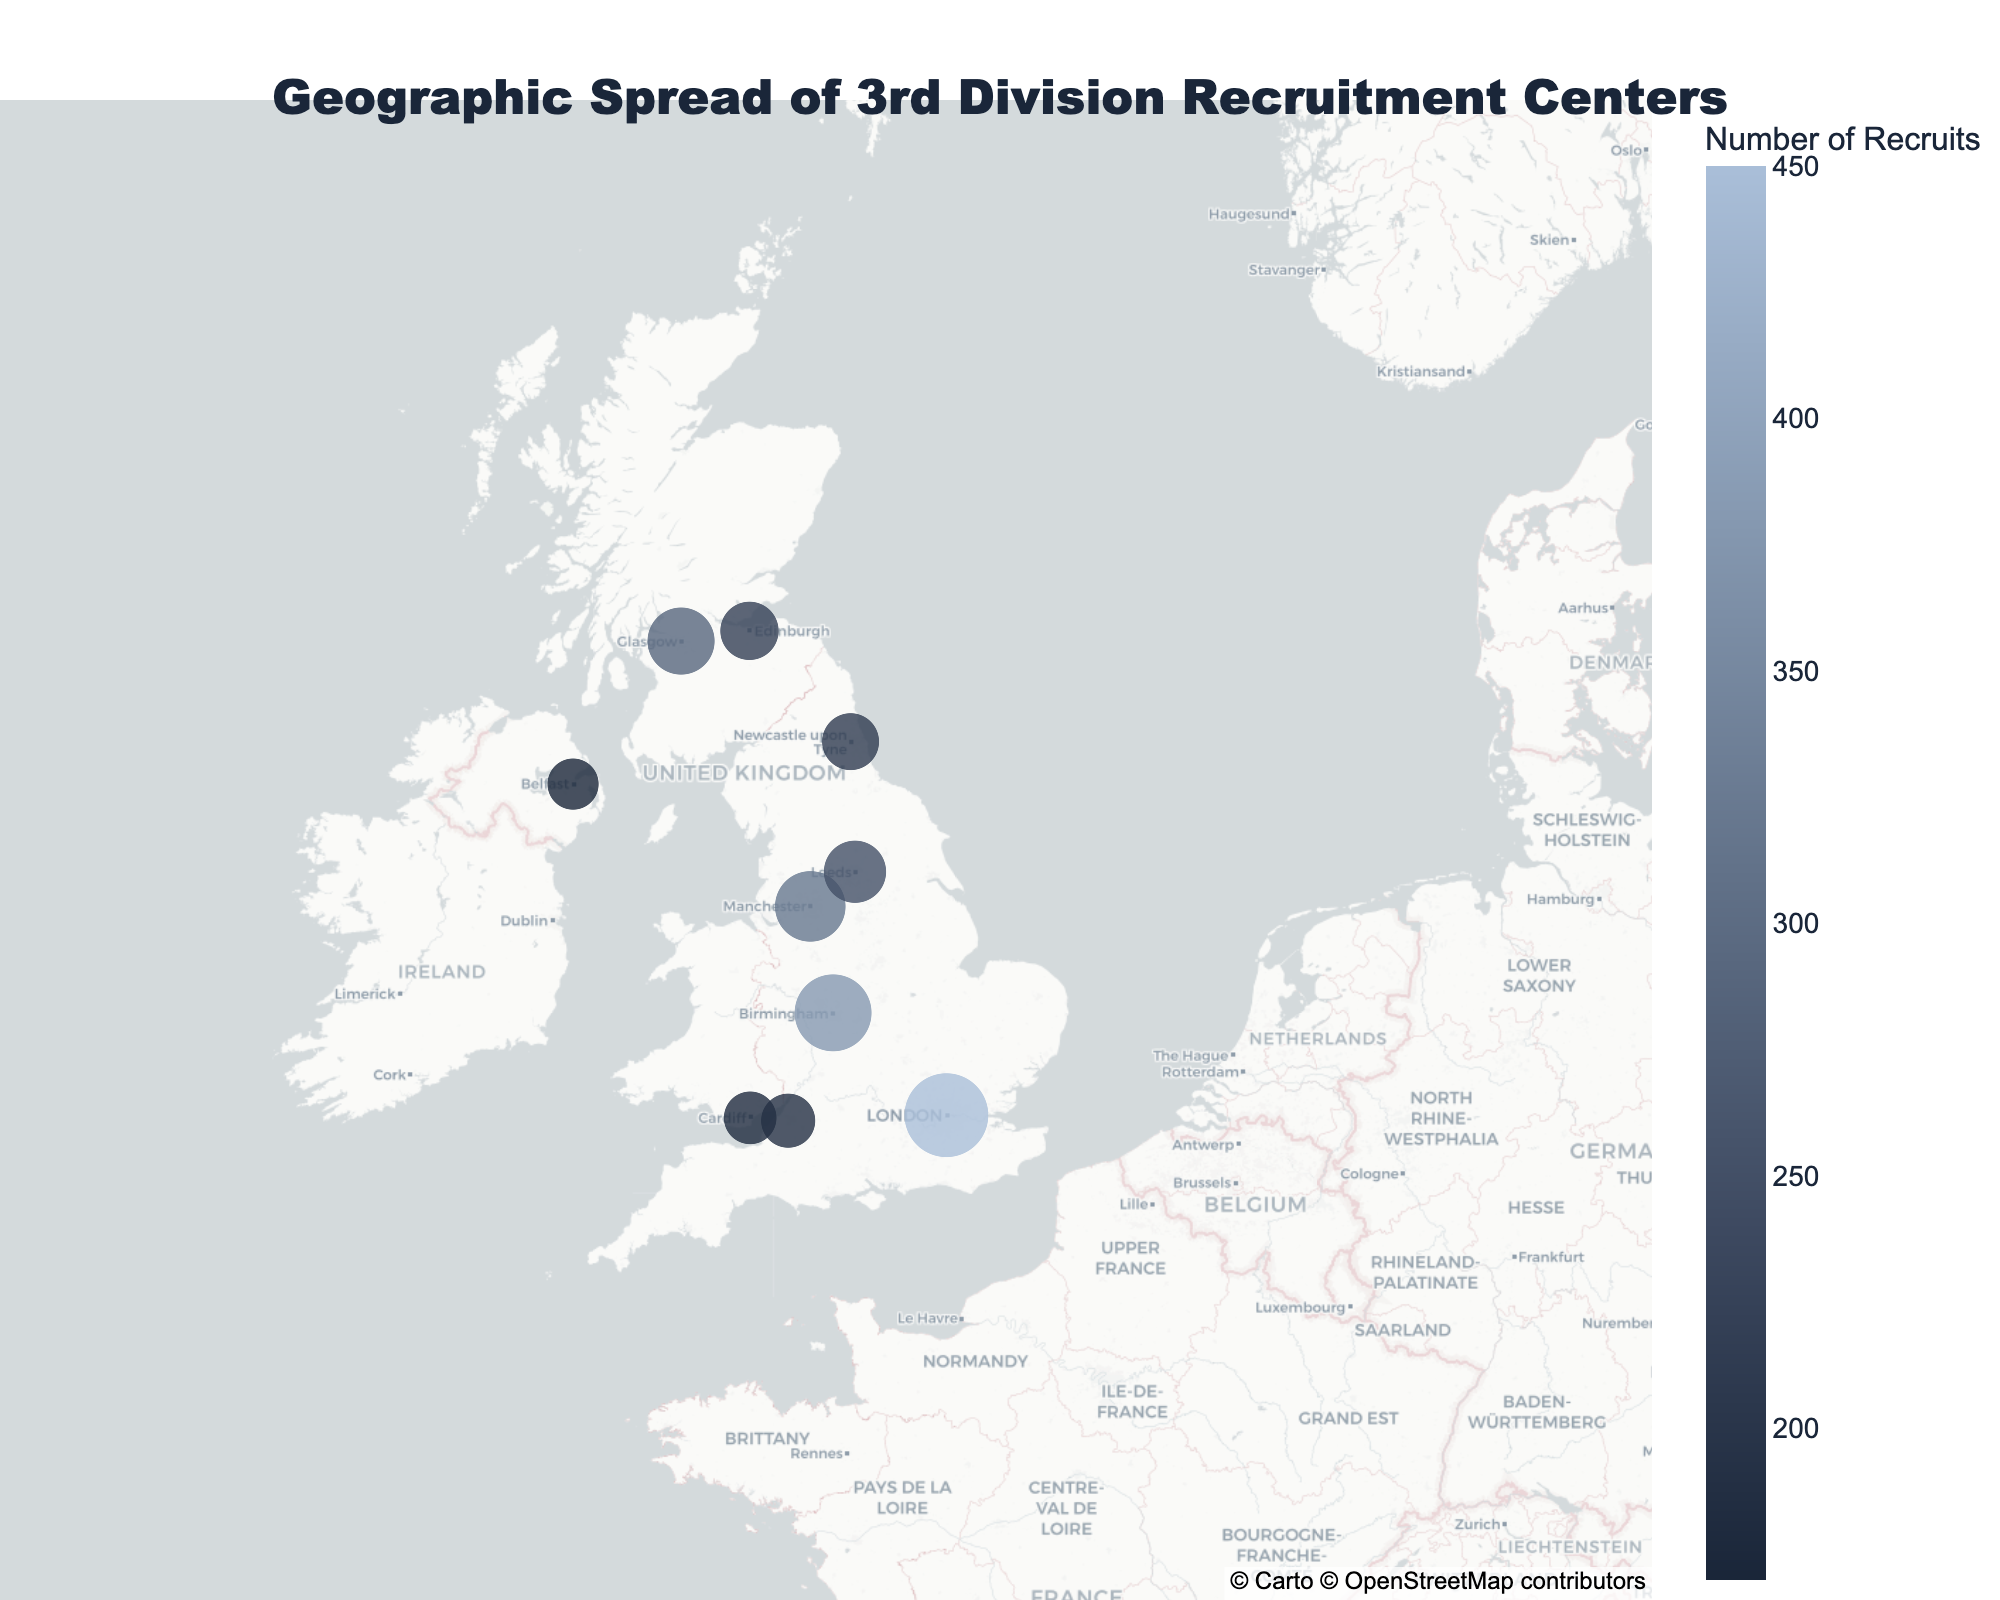What is the title of the map? Look at the top of the map to read the title, which summarizes the content of the figure.
Answer: Geographic Spread of 3rd Division Recruitment Centers Which city has the highest number of recruits? Locate the markers on the map, which vary in size based on the number of recruits. The largest marker indicates the city with the highest number of recruits.
Answer: London How many cities have recruit numbers greater than 300? Identify the cities with recruit numbers and count those figures that are greater than 300.
Answer: Three (London, Manchester, Birmingham) What is the average number of recruits among all cities? Add up the number of recruits from all the cities and divide by the number of cities. (450 + 320 + 380 + 290 + 210 + 180 + 250 + 220 + 190 + 170) / 10 = 266
Answer: 266 Which city has the second-highest number of recruits? Locate the city with the highest number of recruits and then find the city with the next largest number of recruits.
Answer: Birmingham How many cities are located in Scotland? Identify the cities that are geographically located in Scotland.
Answer: Two (Glasgow and Edinburgh) Compare the number of recruits between Belfast and Cardiff. Which city has more recruits? Examine the markers representing Belfast and Cardiff and compare their recruit numbers.
Answer: Cardiff What is the total number of recruits from cities in Wales and Northern Ireland? Add the number of recruits from Cardiff (Wales) and Belfast (Northern Ireland). 180 + 170 = 350
Answer: 350 Identify the city with the smallest number of recruits. Locate the smallest marker on the map, which indicates the city with the fewest recruits.
Answer: Belfast What is the distance between the recruitment centers in Edinburgh and Glasgow? Determine the approximate geographical distance between the two cities located in Scotland on the map. This involves visual estimation or using geographic knowledge.
Answer: Approximately 50 miles 